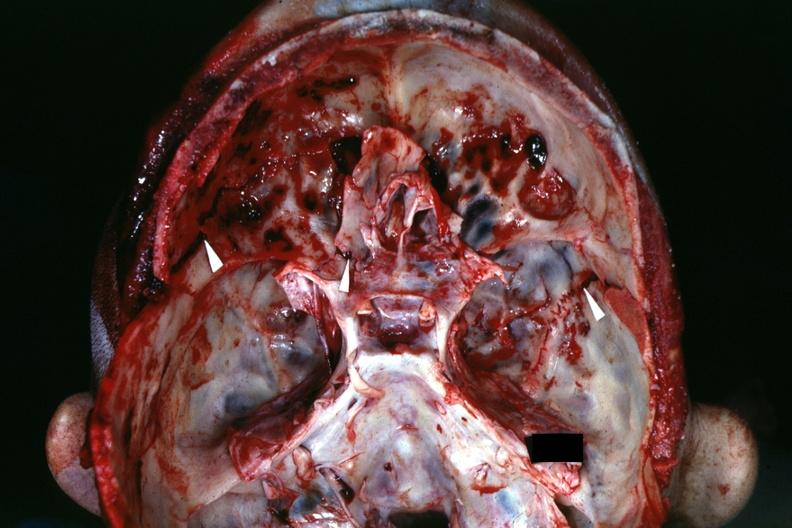s this good yellow color slide present?
Answer the question using a single word or phrase. No 